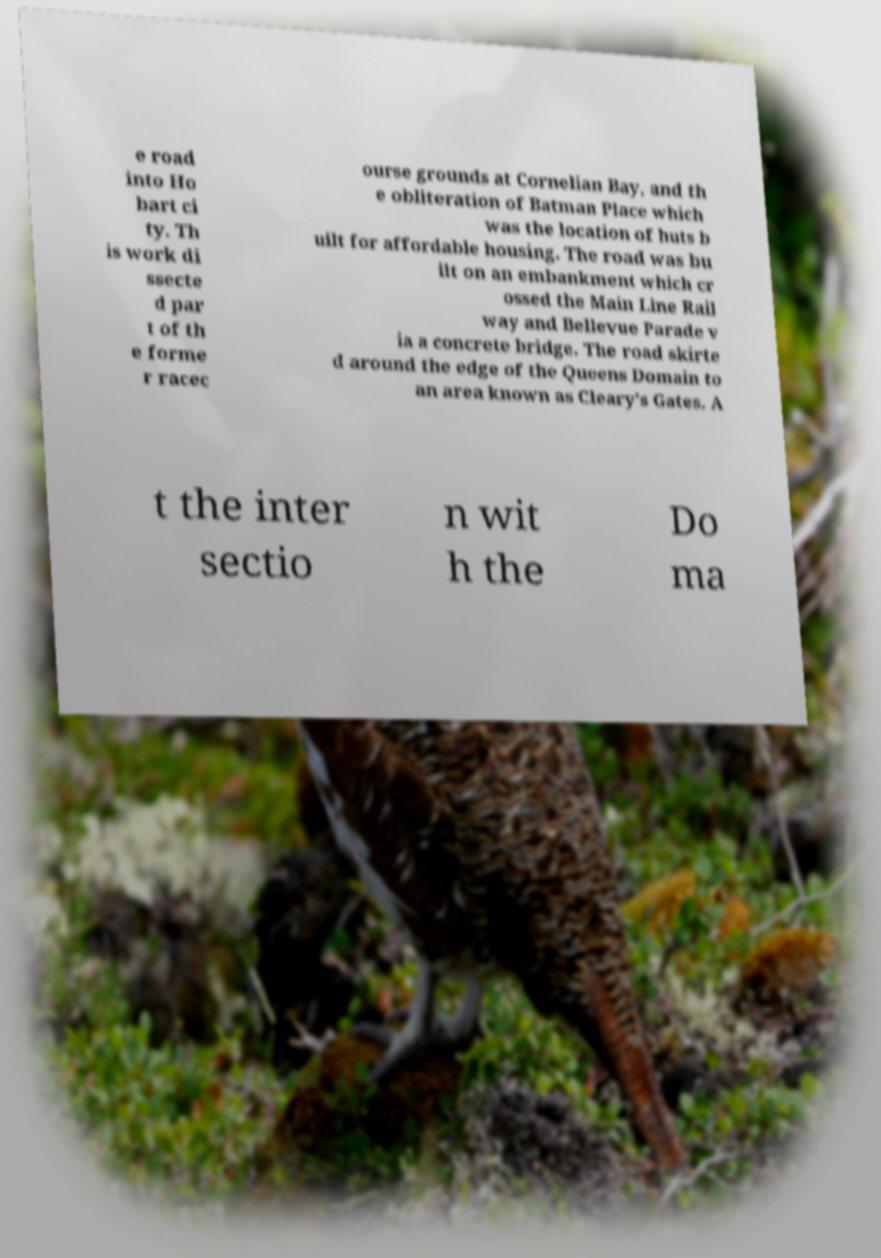There's text embedded in this image that I need extracted. Can you transcribe it verbatim? e road into Ho bart ci ty. Th is work di ssecte d par t of th e forme r racec ourse grounds at Cornelian Bay, and th e obliteration of Batman Place which was the location of huts b uilt for affordable housing. The road was bu ilt on an embankment which cr ossed the Main Line Rail way and Bellevue Parade v ia a concrete bridge. The road skirte d around the edge of the Queens Domain to an area known as Cleary's Gates. A t the inter sectio n wit h the Do ma 